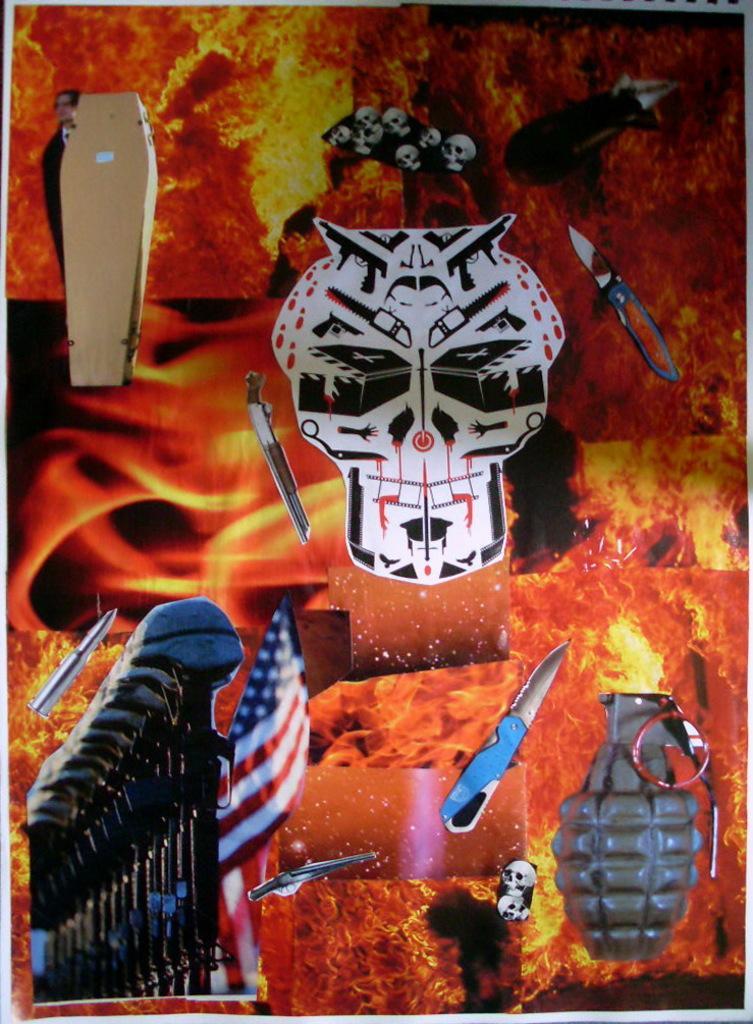Please provide a concise description of this image. In this picture we can see a poster, in this poster we can see knives, flag, person and images. 